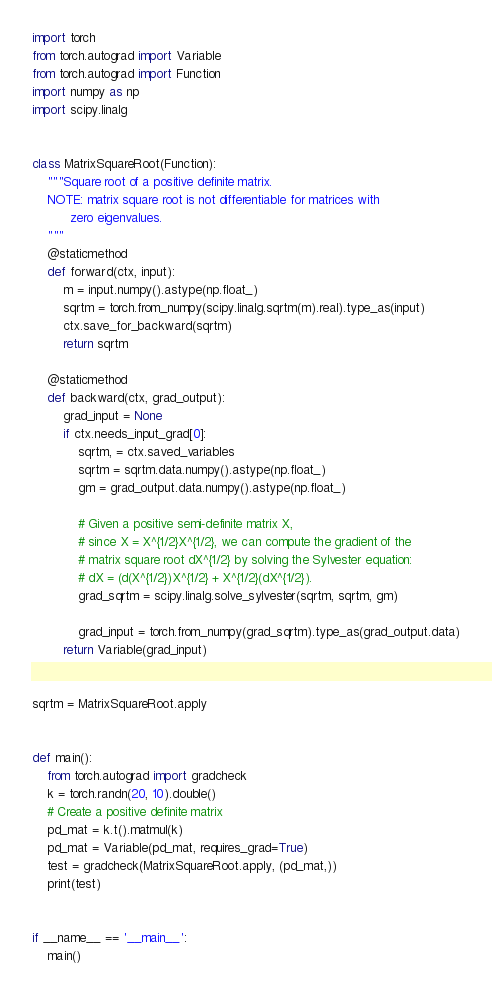<code> <loc_0><loc_0><loc_500><loc_500><_Python_>import torch
from torch.autograd import Variable
from torch.autograd import Function
import numpy as np
import scipy.linalg


class MatrixSquareRoot(Function):
    """Square root of a positive definite matrix.
    NOTE: matrix square root is not differentiable for matrices with
          zero eigenvalues.
    """
    @staticmethod
    def forward(ctx, input):
        m = input.numpy().astype(np.float_)
        sqrtm = torch.from_numpy(scipy.linalg.sqrtm(m).real).type_as(input)
        ctx.save_for_backward(sqrtm)
        return sqrtm

    @staticmethod
    def backward(ctx, grad_output):
        grad_input = None
        if ctx.needs_input_grad[0]:
            sqrtm, = ctx.saved_variables
            sqrtm = sqrtm.data.numpy().astype(np.float_)
            gm = grad_output.data.numpy().astype(np.float_)

            # Given a positive semi-definite matrix X,
            # since X = X^{1/2}X^{1/2}, we can compute the gradient of the
            # matrix square root dX^{1/2} by solving the Sylvester equation:
            # dX = (d(X^{1/2})X^{1/2} + X^{1/2}(dX^{1/2}).
            grad_sqrtm = scipy.linalg.solve_sylvester(sqrtm, sqrtm, gm)

            grad_input = torch.from_numpy(grad_sqrtm).type_as(grad_output.data)
        return Variable(grad_input)


sqrtm = MatrixSquareRoot.apply


def main():
    from torch.autograd import gradcheck
    k = torch.randn(20, 10).double()
    # Create a positive definite matrix
    pd_mat = k.t().matmul(k)
    pd_mat = Variable(pd_mat, requires_grad=True)
    test = gradcheck(MatrixSquareRoot.apply, (pd_mat,))
    print(test)


if __name__ == '__main__':
    main()</code> 